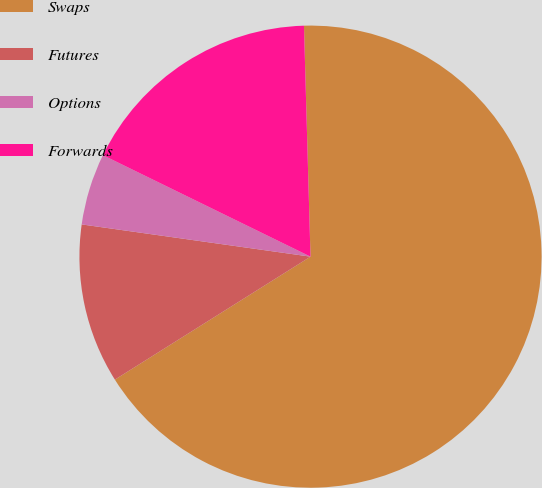Convert chart to OTSL. <chart><loc_0><loc_0><loc_500><loc_500><pie_chart><fcel>Swaps<fcel>Futures<fcel>Options<fcel>Forwards<nl><fcel>66.52%<fcel>11.16%<fcel>5.01%<fcel>17.31%<nl></chart> 